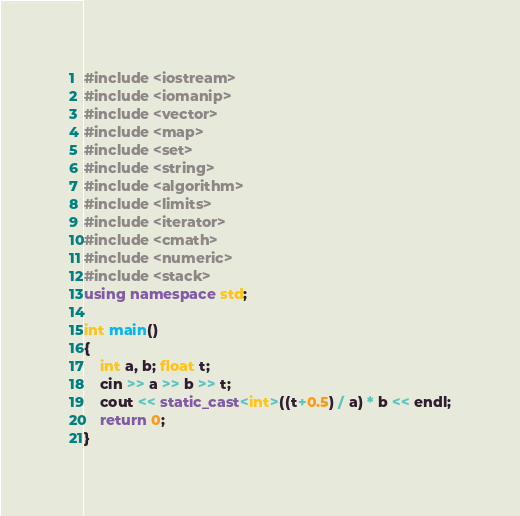<code> <loc_0><loc_0><loc_500><loc_500><_C++_>#include <iostream>
#include <iomanip>
#include <vector>
#include <map>
#include <set>
#include <string>
#include <algorithm>
#include <limits>
#include <iterator>
#include <cmath>
#include <numeric>
#include <stack>
using namespace std;

int main()
{
	int a, b; float t;
	cin >> a >> b >> t;
	cout << static_cast<int>((t+0.5) / a) * b << endl;
	return 0;
}</code> 